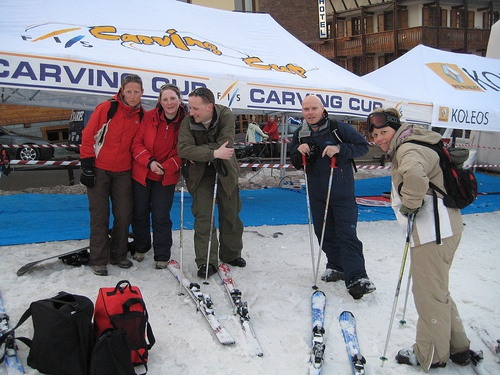Describe the objects in this image and their specific colors. I can see people in lightblue, gray, black, and darkgray tones, people in lightblue, black, gray, and darkgray tones, people in lightblue, black, and gray tones, people in lightblue, black, brown, and maroon tones, and people in lightblue, black, brown, maroon, and gray tones in this image. 